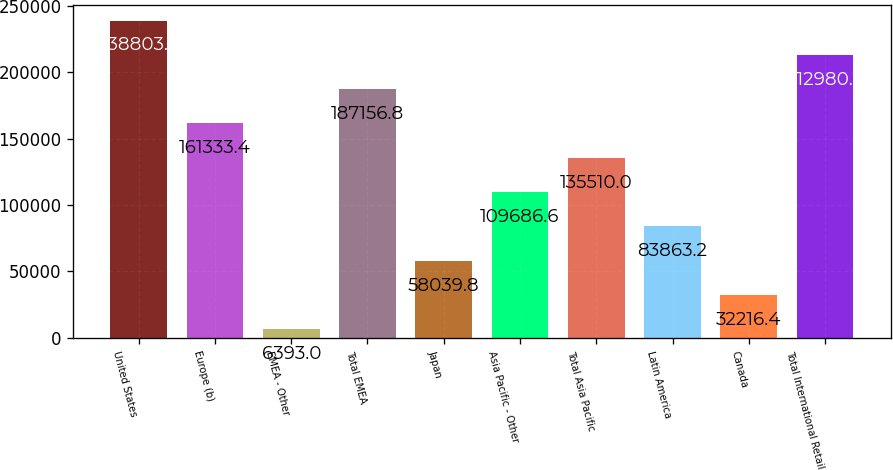Convert chart to OTSL. <chart><loc_0><loc_0><loc_500><loc_500><bar_chart><fcel>United States<fcel>Europe (b)<fcel>EMEA - Other<fcel>Total EMEA<fcel>Japan<fcel>Asia Pacific - Other<fcel>Total Asia Pacific<fcel>Latin America<fcel>Canada<fcel>Total International Retail<nl><fcel>238804<fcel>161333<fcel>6393<fcel>187157<fcel>58039.8<fcel>109687<fcel>135510<fcel>83863.2<fcel>32216.4<fcel>212980<nl></chart> 